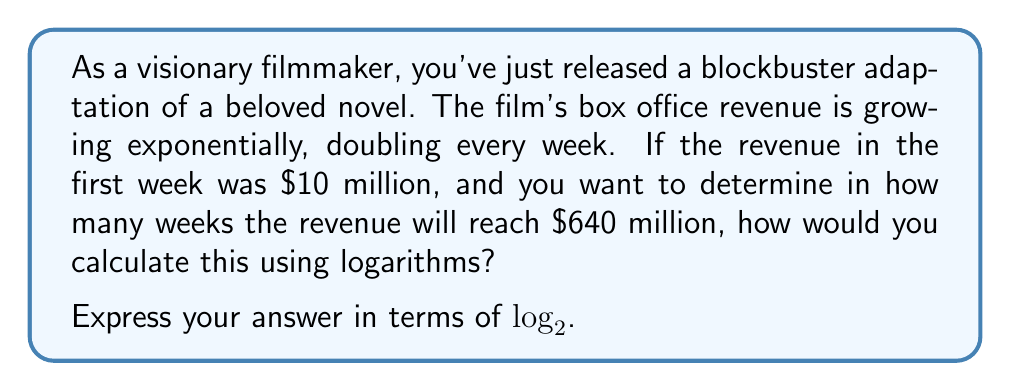Provide a solution to this math problem. Let's approach this step-by-step using logarithms:

1) Let $x$ be the number of weeks we're looking for.

2) We can express the revenue after $x$ weeks as:
   $10 \cdot 2^x = 640$ (million dollars)

3) To solve this, we can use logarithms. Let's apply $\log_2$ to both sides:
   $\log_2(10 \cdot 2^x) = \log_2(640)$

4) Using the logarithm product rule:
   $\log_2(10) + \log_2(2^x) = \log_2(640)$

5) Simplify $\log_2(2^x)$:
   $\log_2(10) + x = \log_2(640)$

6) Now we can solve for $x$:
   $x = \log_2(640) - \log_2(10)$

7) We can further simplify this using the logarithm quotient rule:
   $x = \log_2(\frac{640}{10}) = \log_2(64)$

Therefore, the number of weeks it will take for the revenue to reach $640 million is $\log_2(64)$.
Answer: $\log_2(64)$ weeks 